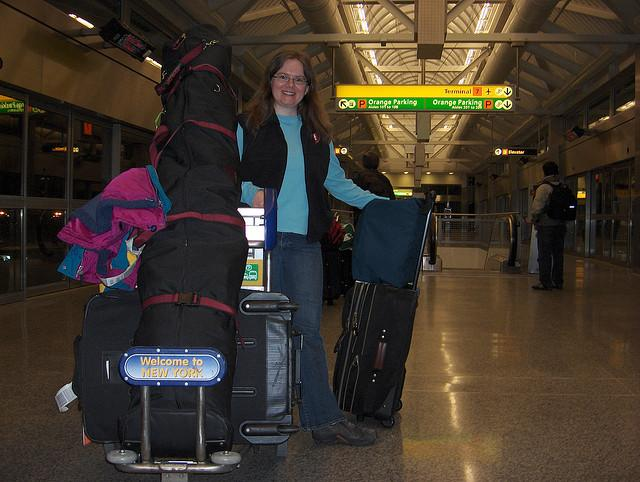What color are the straps wrapping up the black duffel on the luggage rack?

Choices:
A) beige
B) purple
C) orange
D) blue purple 